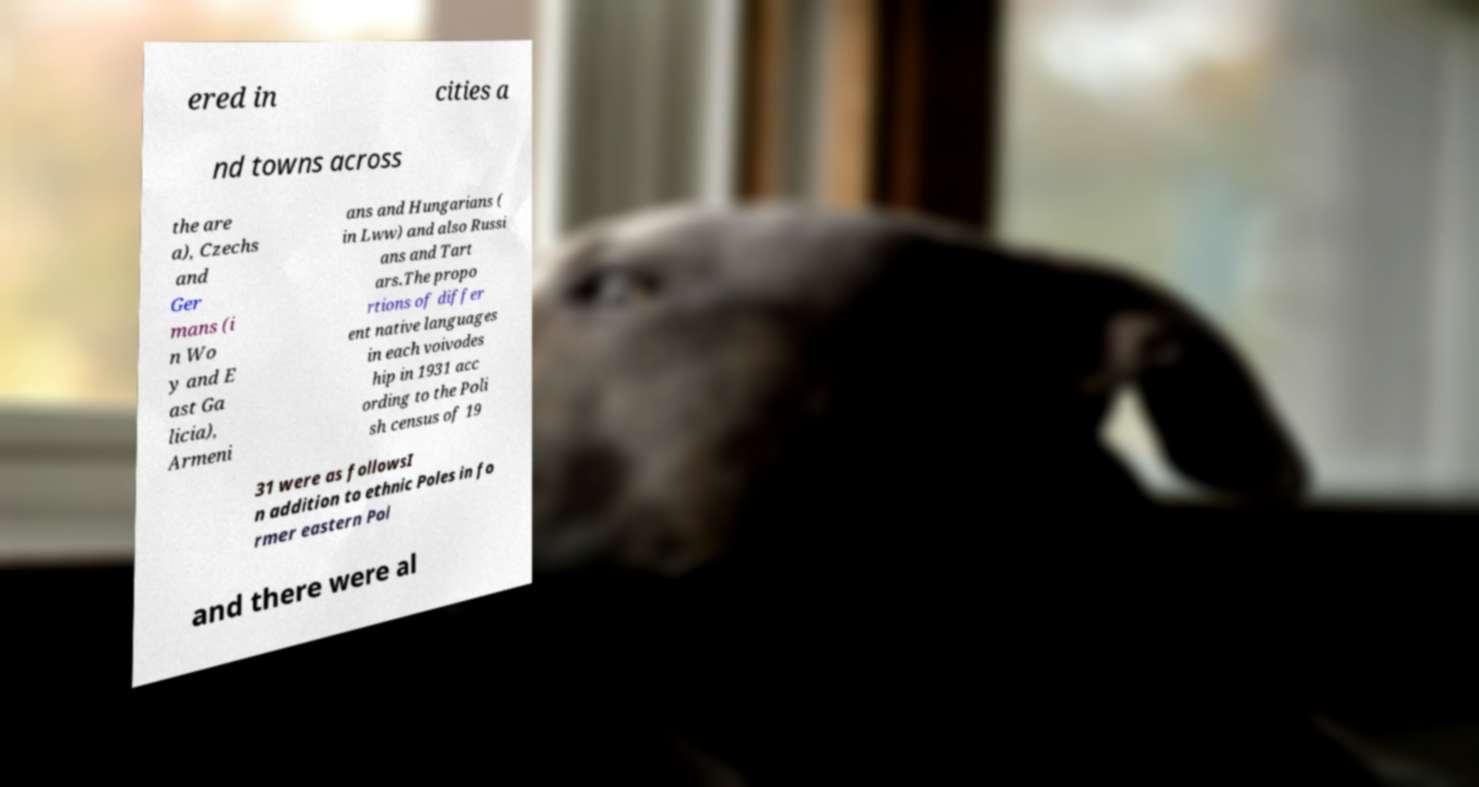Can you accurately transcribe the text from the provided image for me? ered in cities a nd towns across the are a), Czechs and Ger mans (i n Wo y and E ast Ga licia), Armeni ans and Hungarians ( in Lww) and also Russi ans and Tart ars.The propo rtions of differ ent native languages in each voivodes hip in 1931 acc ording to the Poli sh census of 19 31 were as followsI n addition to ethnic Poles in fo rmer eastern Pol and there were al 